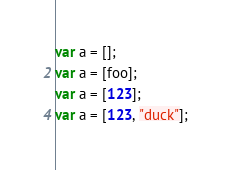<code> <loc_0><loc_0><loc_500><loc_500><_JavaScript_>var a = [];
var a = [foo];
var a = [123];
var a = [123, "duck"];
</code> 